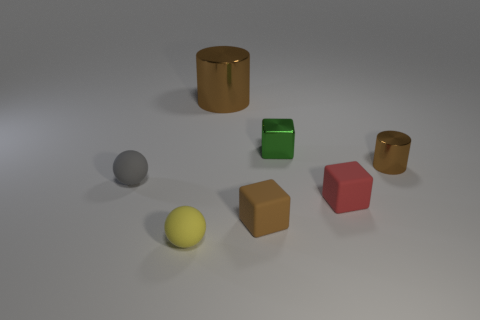Do the brown rubber thing and the gray rubber thing have the same size?
Your answer should be compact. Yes. Is there anything else that is the same color as the big shiny thing?
Give a very brief answer. Yes. The brown thing that is to the left of the small brown metal cylinder and right of the large metal cylinder has what shape?
Make the answer very short. Cube. What is the size of the brown cylinder that is in front of the big brown metallic cylinder?
Keep it short and to the point. Small. How many tiny brown rubber cubes are behind the brown cylinder right of the brown metal cylinder that is on the left side of the small cylinder?
Give a very brief answer. 0. Are there any tiny brown rubber things in front of the tiny metal cube?
Your answer should be very brief. Yes. What number of other things are the same size as the green metallic thing?
Give a very brief answer. 5. There is a tiny thing that is both on the left side of the small brown matte thing and to the right of the gray ball; what material is it?
Make the answer very short. Rubber. There is a tiny brown object that is behind the tiny brown rubber block; is its shape the same as the small brown object that is left of the tiny green metal block?
Give a very brief answer. No. Is there any other thing that is made of the same material as the large brown thing?
Ensure brevity in your answer.  Yes. 